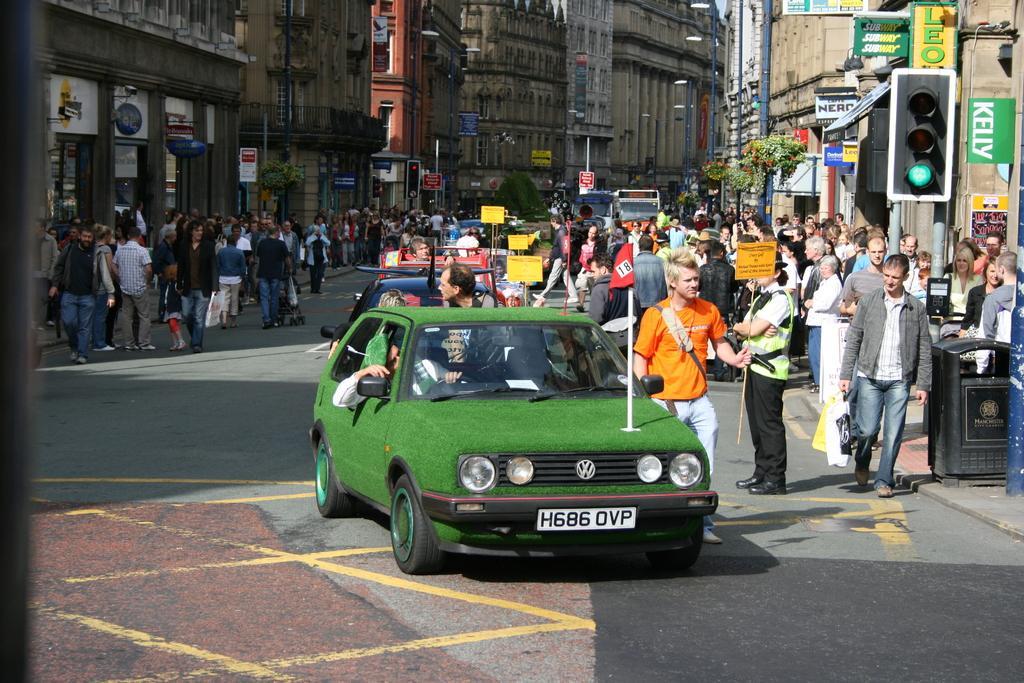Describe this image in one or two sentences. This picture is clicked outside the city. In the middle of the picture, we see cars moving on the road. On either side of the road, we see people walking on the footpath. We even see buildings. On the right side, we see traffic signal, garbage bin and hoarding boards. There are buildings in the background. 